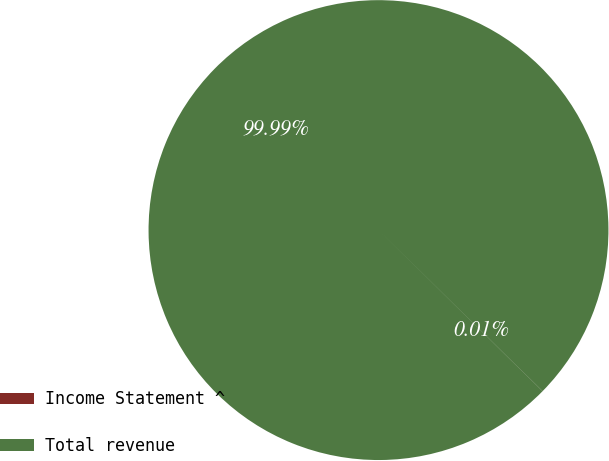Convert chart to OTSL. <chart><loc_0><loc_0><loc_500><loc_500><pie_chart><fcel>Income Statement ^<fcel>Total revenue<nl><fcel>0.01%<fcel>99.99%<nl></chart> 